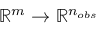<formula> <loc_0><loc_0><loc_500><loc_500>{ \mathbb { R } } ^ { m } \rightarrow { \mathbb { R } } ^ { n _ { o b s } }</formula> 